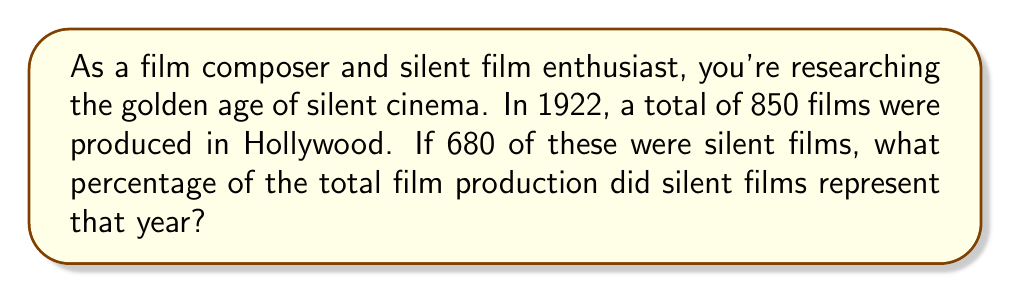Could you help me with this problem? To solve this problem, we need to follow these steps:

1. Identify the total number of films produced: 850
2. Identify the number of silent films: 680
3. Set up the percentage calculation:

   Percentage = $\frac{\text{Number of silent films}}{\text{Total number of films}} \times 100\%$

4. Plug in the values:

   Percentage = $\frac{680}{850} \times 100\%$

5. Simplify the fraction:
   $\frac{680}{850} = \frac{68}{85}$

6. Perform the division:
   $\frac{68}{85} \approx 0.8$

7. Multiply by 100% to get the final percentage:
   $0.8 \times 100\% = 80\%$

Therefore, silent films represented 80% of the total film production in 1922.
Answer: 80% 